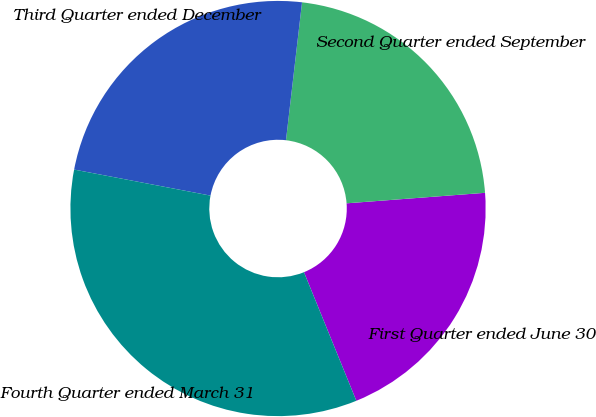Convert chart. <chart><loc_0><loc_0><loc_500><loc_500><pie_chart><fcel>First Quarter ended June 30<fcel>Second Quarter ended September<fcel>Third Quarter ended December<fcel>Fourth Quarter ended March 31<nl><fcel>20.05%<fcel>21.95%<fcel>23.84%<fcel>34.16%<nl></chart> 